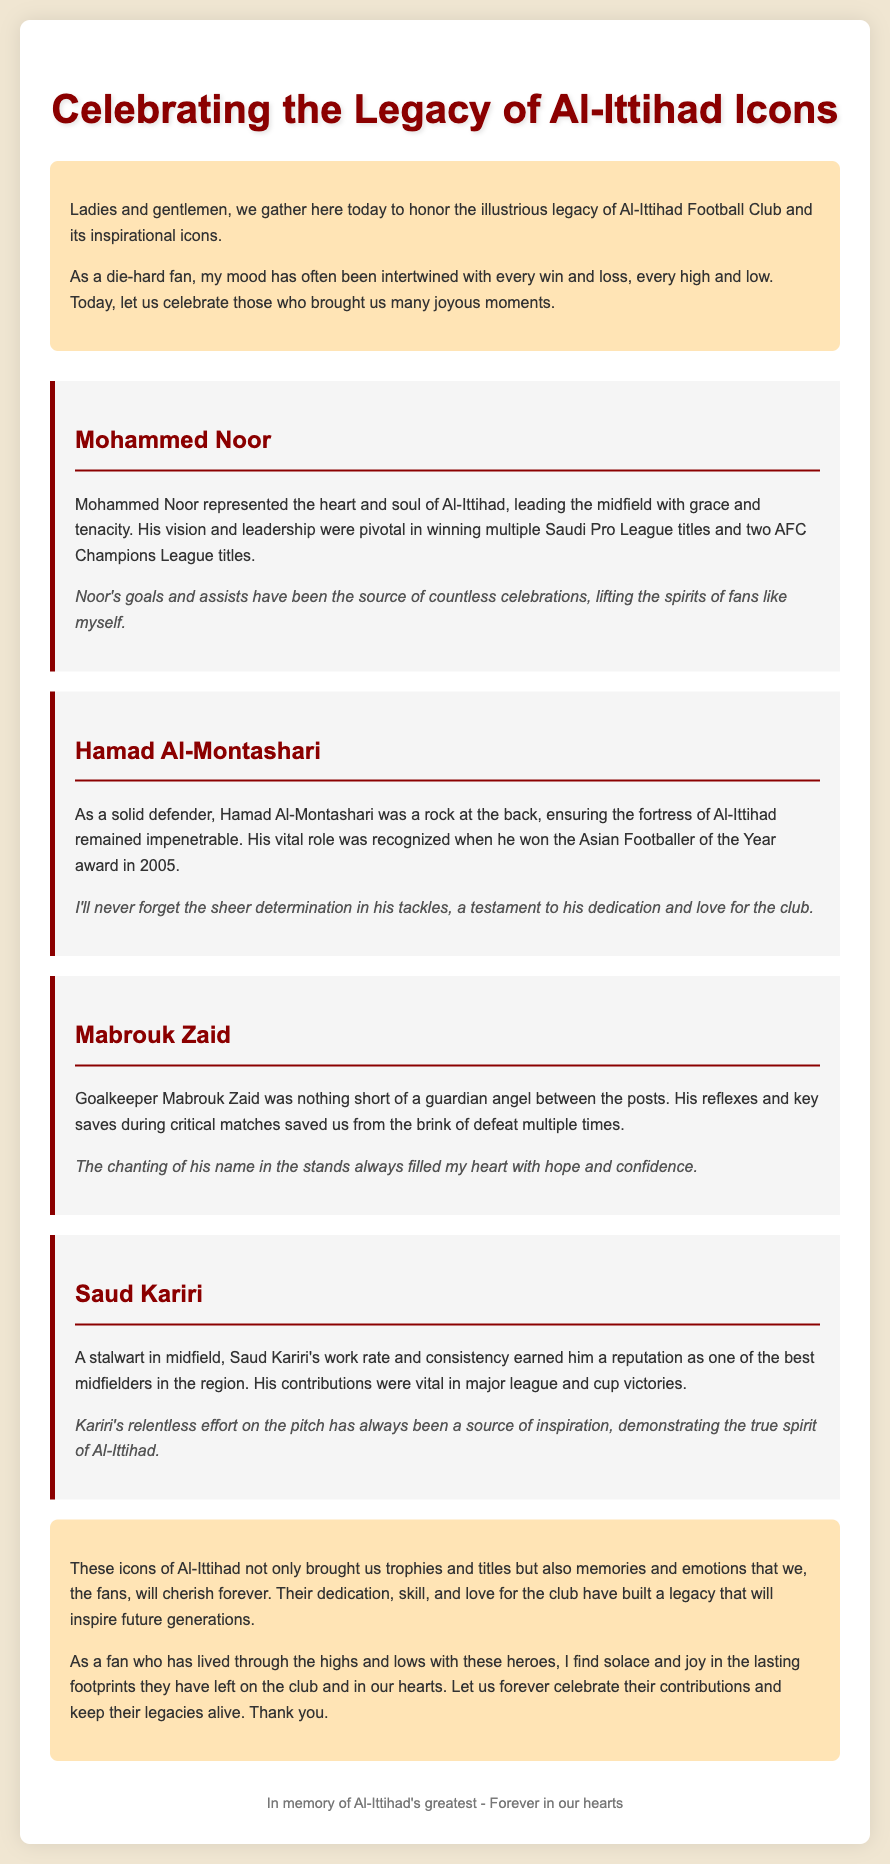what is the title of the eulogy? The title of the eulogy is prominently displayed at the top of the document.
Answer: Celebrating the Legacy of Al-Ittihad Icons who is described as the heart and soul of Al-Ittihad? This information is stated in the section about Mohammed Noor.
Answer: Mohammed Noor which player won the Asian Footballer of the Year award in 2005? This detail is specifically mentioned in the description of Hamad Al-Montashari.
Answer: Hamad Al-Montashari how many AFC Champions League titles did Mohammed Noor win? The number of titles won is mentioned directly in his section.
Answer: two what emotional effect did Mabrouk Zaid's performances have on the fans? This sentiment is expressed in relation to the chanting of his name.
Answer: hope and confidence which player's effort is described as a source of inspiration? This is mentioned in the section about Saud Kariri.
Answer: Saud Kariri what common theme is celebrated in the eulogy? The eulogy discusses a specific sentiment repeated in relation to the players' contributions.
Answer: legacy how is the introduction section characterized? This is observed by analyzing its content and structure within the document.
Answer: honoring the legacy 